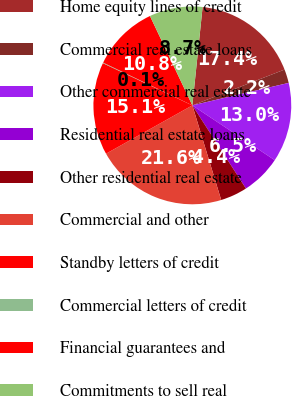Convert chart to OTSL. <chart><loc_0><loc_0><loc_500><loc_500><pie_chart><fcel>Home equity lines of credit<fcel>Commercial real estate loans<fcel>Other commercial real estate<fcel>Residential real estate loans<fcel>Other residential real estate<fcel>Commercial and other<fcel>Standby letters of credit<fcel>Commercial letters of credit<fcel>Financial guarantees and<fcel>Commitments to sell real<nl><fcel>17.45%<fcel>2.25%<fcel>12.99%<fcel>6.55%<fcel>4.4%<fcel>21.59%<fcel>15.14%<fcel>0.1%<fcel>10.84%<fcel>8.7%<nl></chart> 